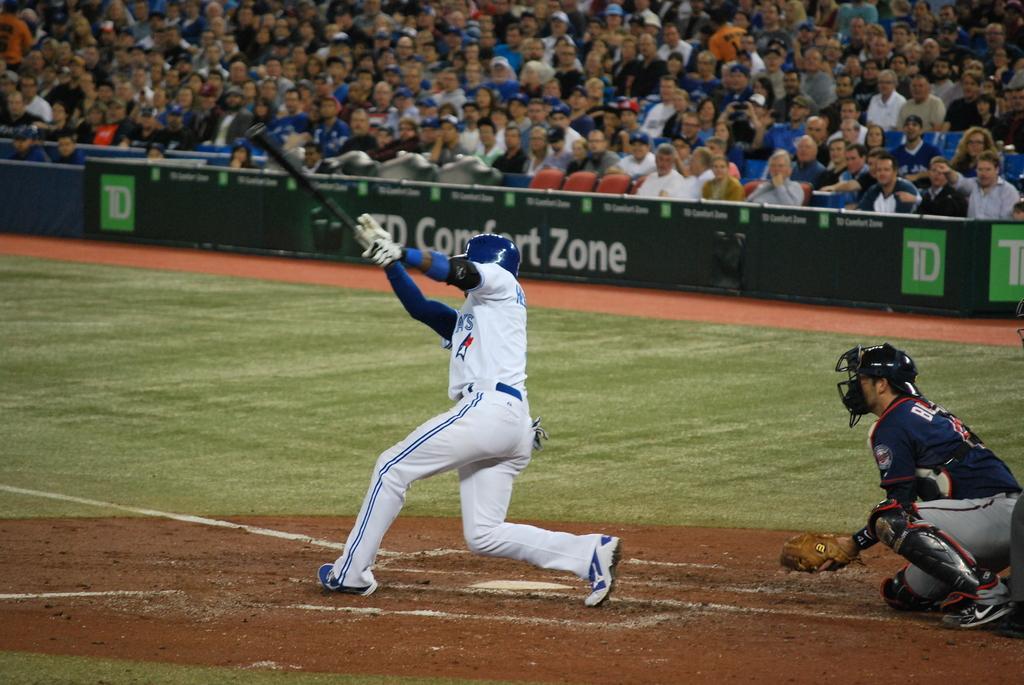Describe this image in one or two sentences. In the image there is a man in white dress holding a baseball bat standing on mud floor, behind him there is another man sitting, this is on baseball field, in the back there are many people sitting on chairs and looking at the game. 